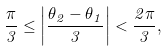<formula> <loc_0><loc_0><loc_500><loc_500>\frac { \pi } { 3 } \leq \left | \frac { \theta _ { 2 } - \theta _ { 1 } } { 3 } \right | < \frac { 2 \pi } { 3 } ,</formula> 